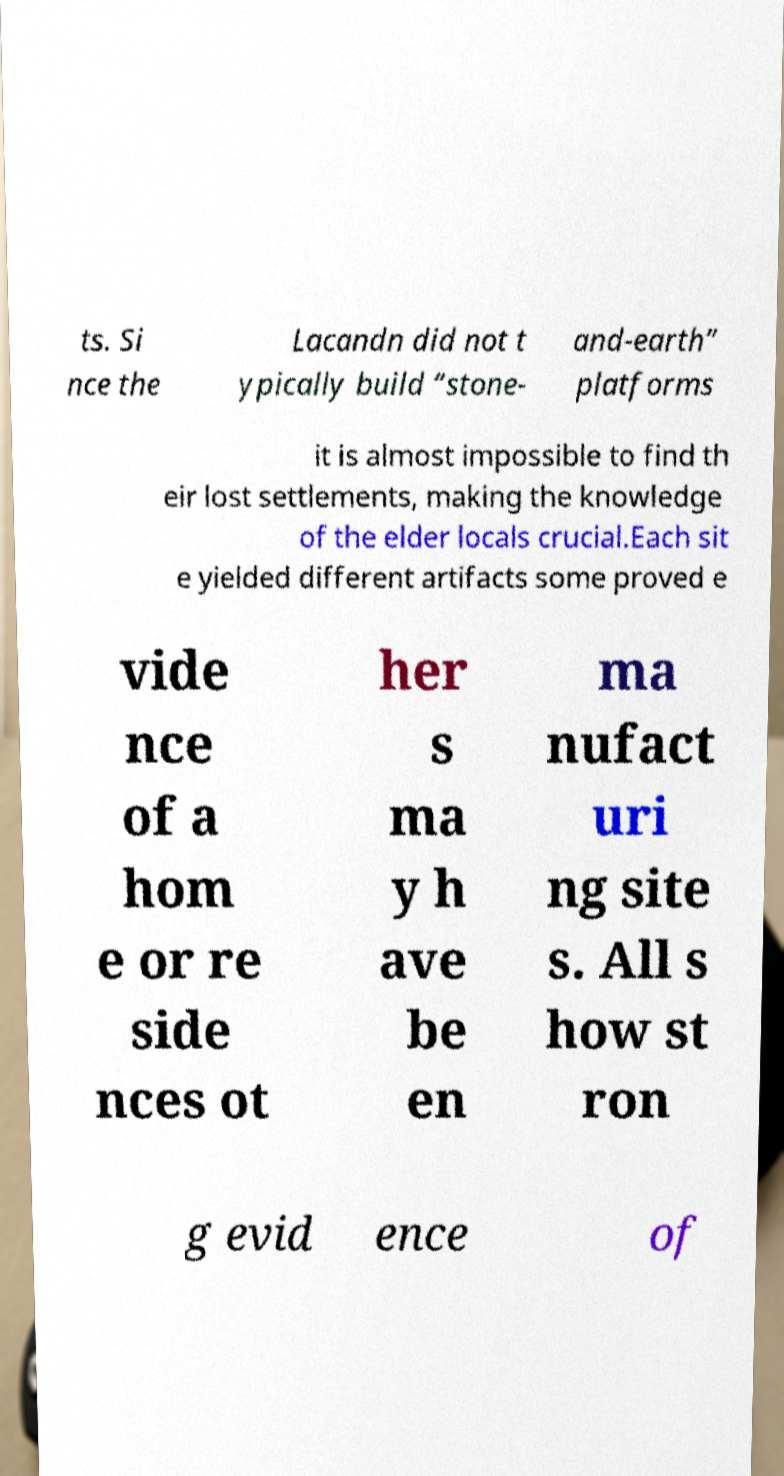What messages or text are displayed in this image? I need them in a readable, typed format. ts. Si nce the Lacandn did not t ypically build “stone- and-earth” platforms it is almost impossible to find th eir lost settlements, making the knowledge of the elder locals crucial.Each sit e yielded different artifacts some proved e vide nce of a hom e or re side nces ot her s ma y h ave be en ma nufact uri ng site s. All s how st ron g evid ence of 